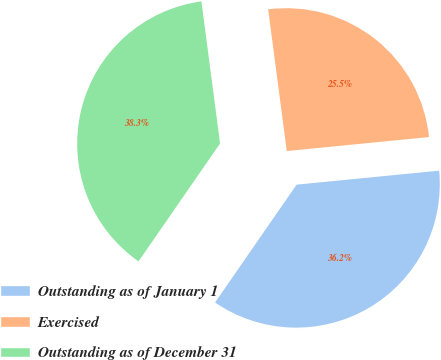Convert chart. <chart><loc_0><loc_0><loc_500><loc_500><pie_chart><fcel>Outstanding as of January 1<fcel>Exercised<fcel>Outstanding as of December 31<nl><fcel>36.19%<fcel>25.52%<fcel>38.29%<nl></chart> 